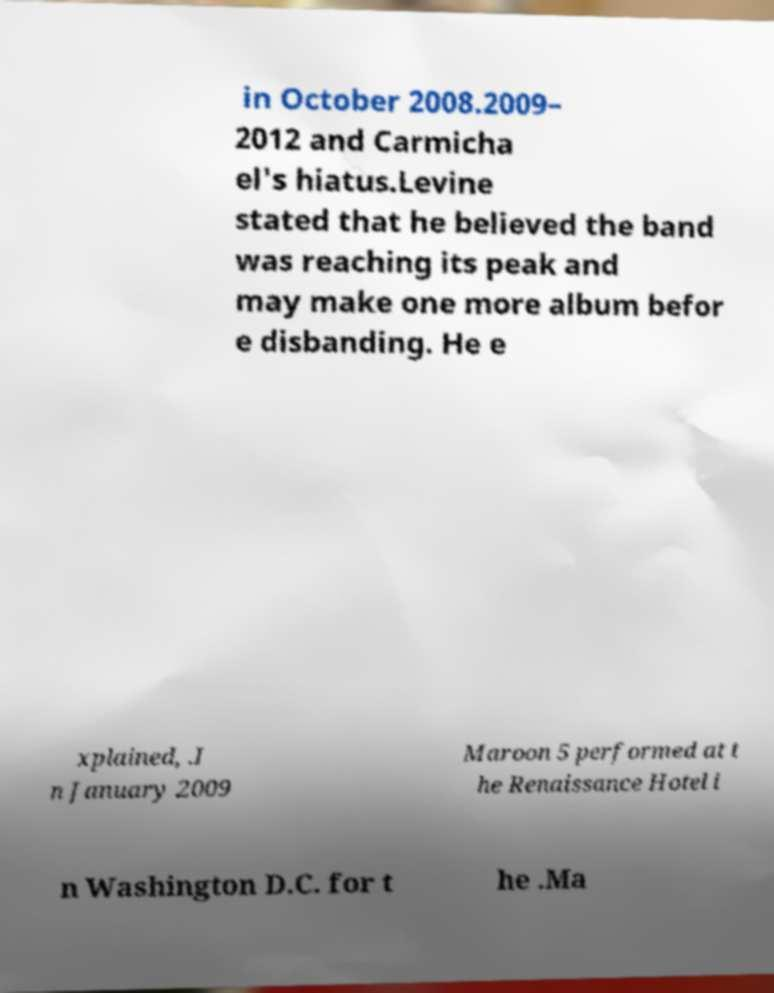Could you assist in decoding the text presented in this image and type it out clearly? in October 2008.2009– 2012 and Carmicha el's hiatus.Levine stated that he believed the band was reaching its peak and may make one more album befor e disbanding. He e xplained, .I n January 2009 Maroon 5 performed at t he Renaissance Hotel i n Washington D.C. for t he .Ma 